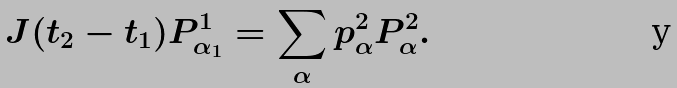<formula> <loc_0><loc_0><loc_500><loc_500>J ( t _ { 2 } - t _ { 1 } ) P ^ { 1 } _ { \alpha _ { 1 } } = \sum _ { \alpha } p ^ { 2 } _ { \alpha } P ^ { 2 } _ { \alpha } .</formula> 